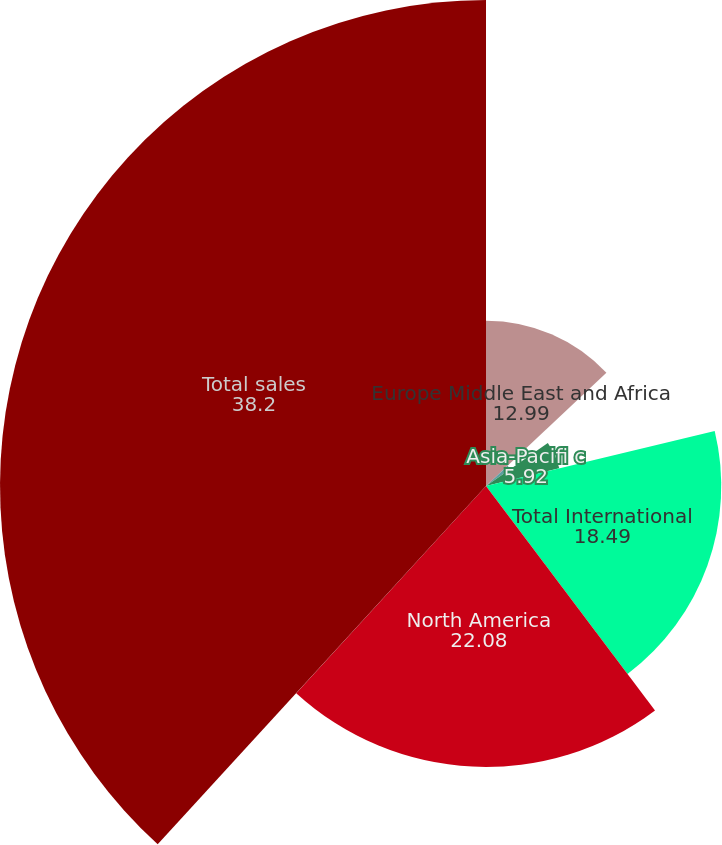Convert chart to OTSL. <chart><loc_0><loc_0><loc_500><loc_500><pie_chart><fcel>Europe Middle East and Africa<fcel>Latin America<fcel>Asia-Pacifi c<fcel>Total International<fcel>North America<fcel>Total sales<nl><fcel>12.99%<fcel>2.33%<fcel>5.92%<fcel>18.49%<fcel>22.08%<fcel>38.2%<nl></chart> 